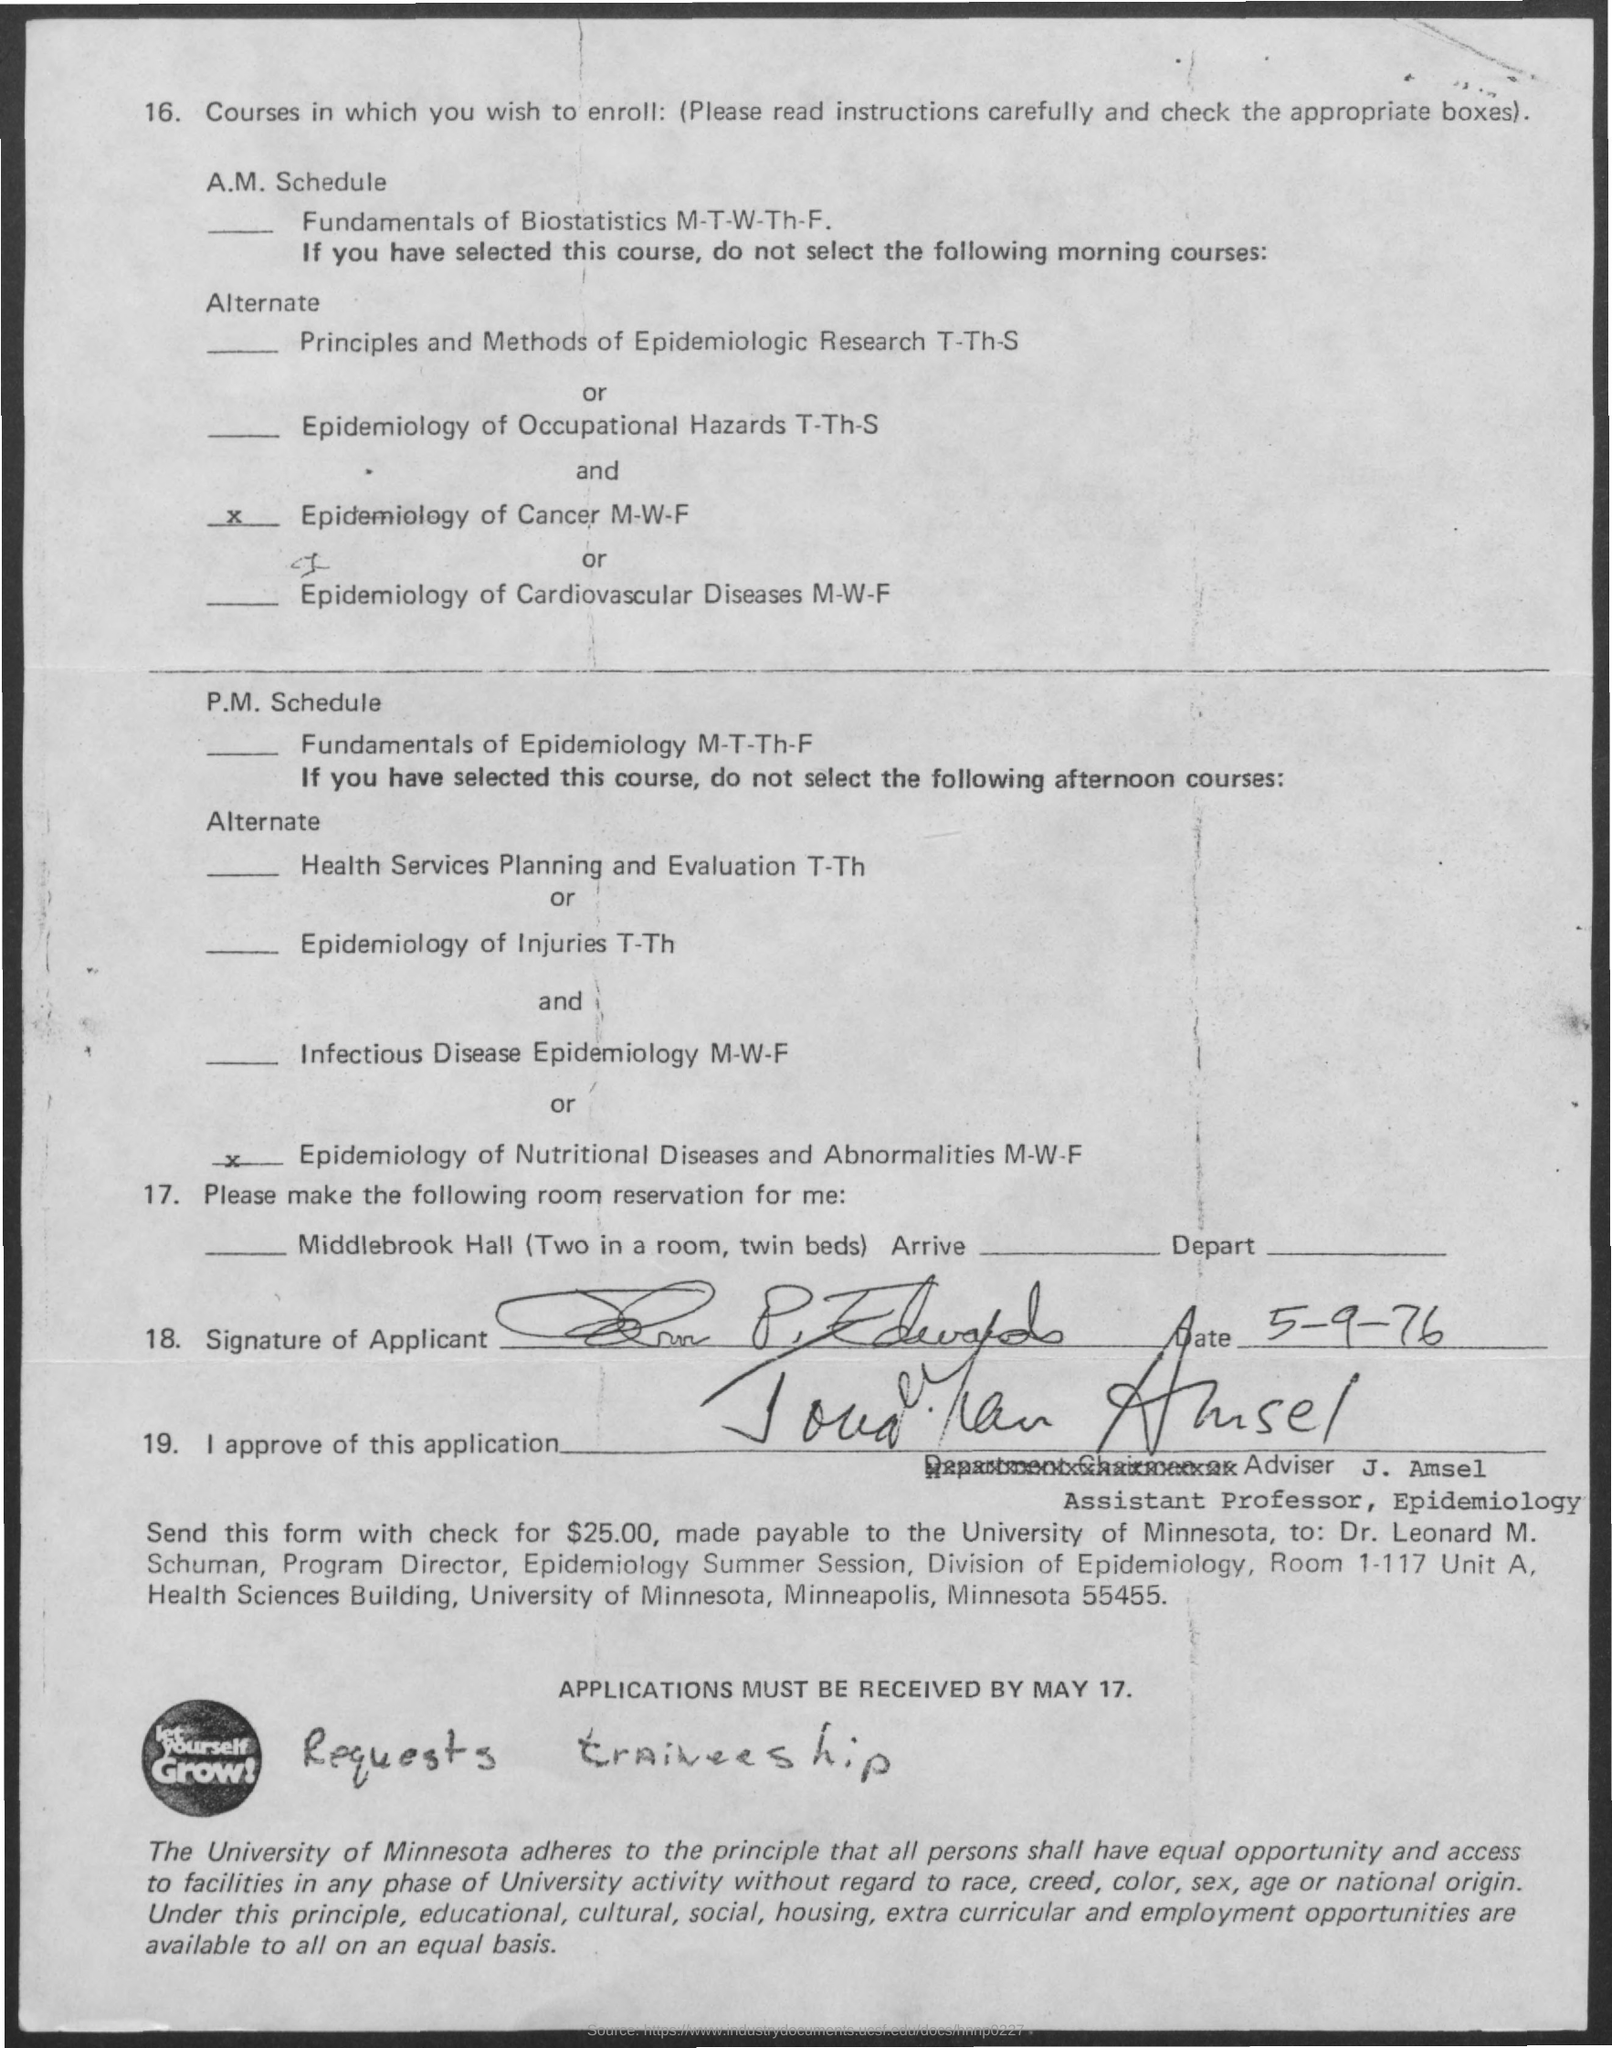What is the date on the document?
Ensure brevity in your answer.  5-9-76. Applications must be received by?
Keep it short and to the point. May 17. 